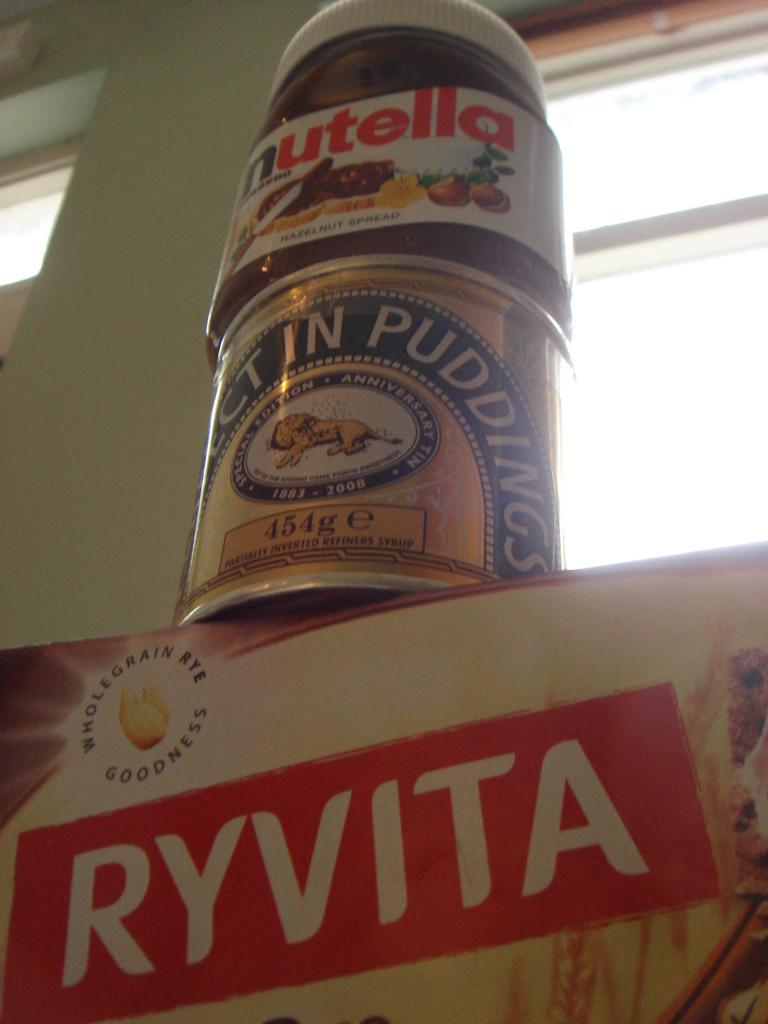Provide a one-sentence caption for the provided image. A jar of nutella atop a can of pudding over a box of ryvita crackers. 